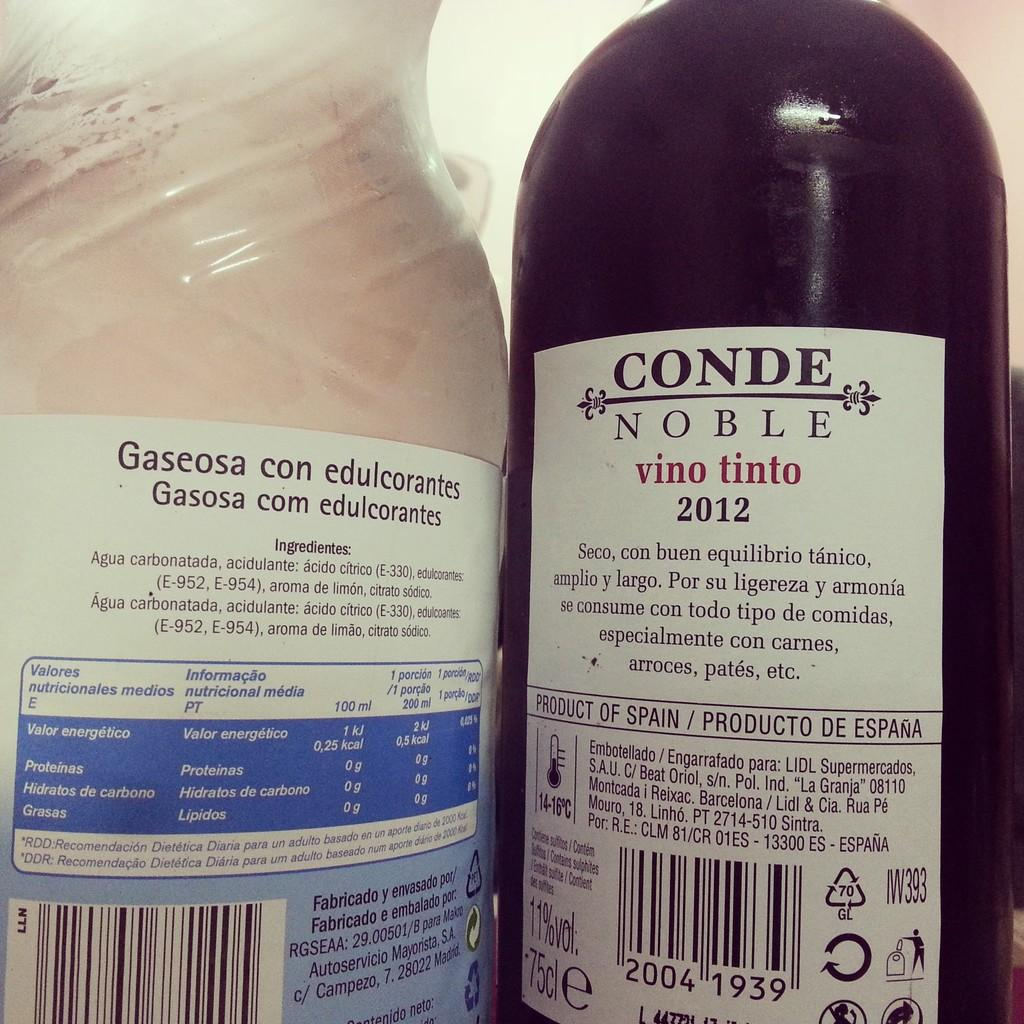<image>
Offer a succinct explanation of the picture presented. Black bottle which says "Conde Noble" on the label. 